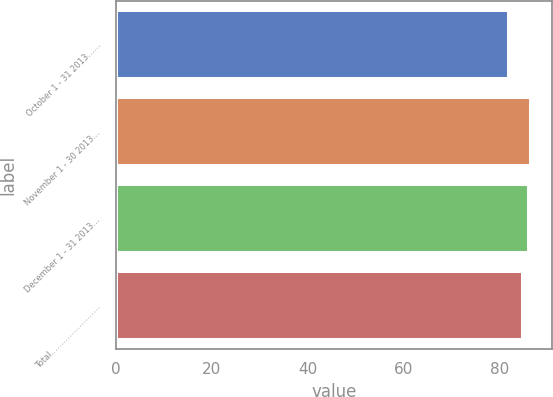Convert chart. <chart><loc_0><loc_0><loc_500><loc_500><bar_chart><fcel>October 1 - 31 2013……<fcel>November 1 - 30 2013…<fcel>December 1 - 31 2013…<fcel>Total……………………<nl><fcel>82.01<fcel>86.56<fcel>86.14<fcel>84.8<nl></chart> 